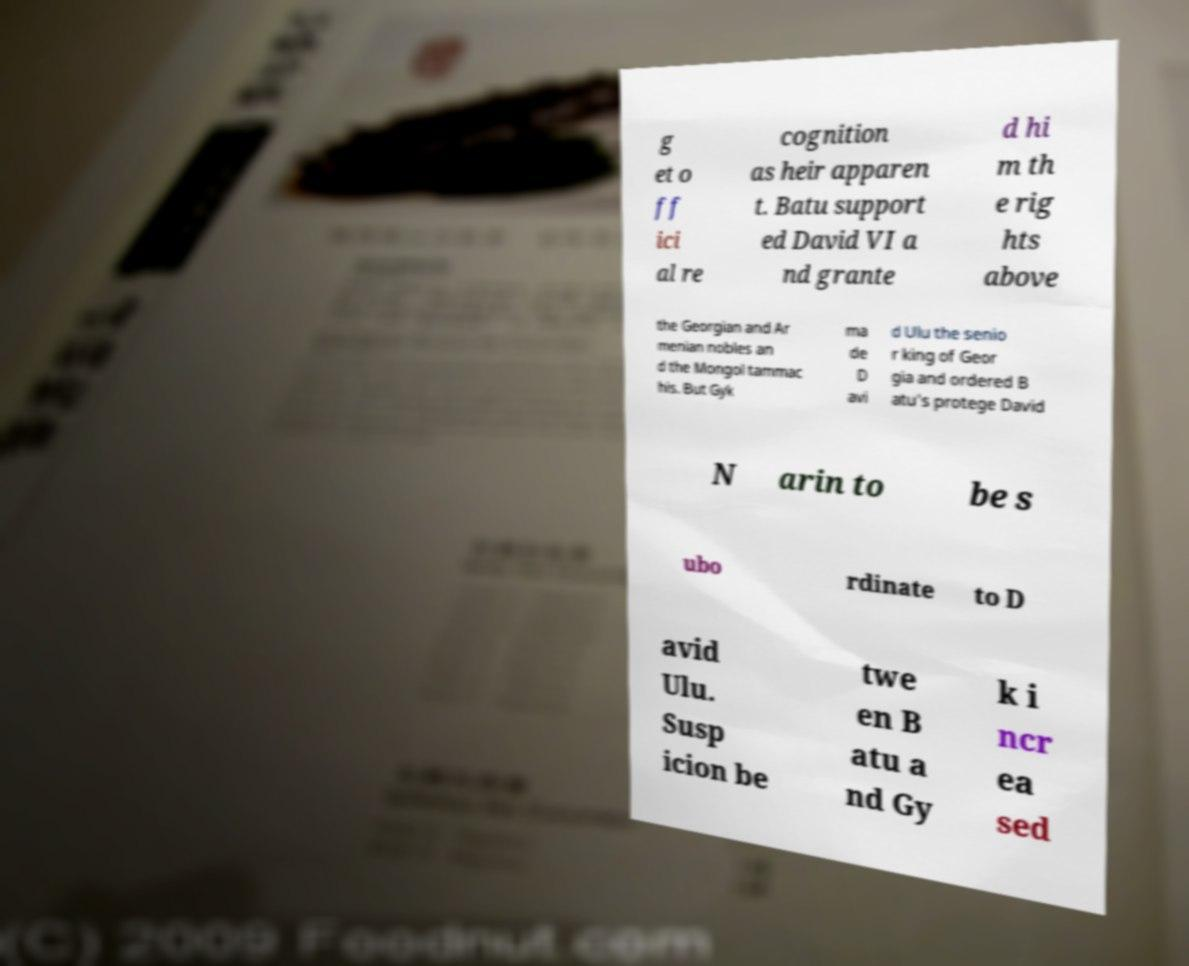Can you accurately transcribe the text from the provided image for me? g et o ff ici al re cognition as heir apparen t. Batu support ed David VI a nd grante d hi m th e rig hts above the Georgian and Ar menian nobles an d the Mongol tammac his. But Gyk ma de D avi d Ulu the senio r king of Geor gia and ordered B atu's protege David N arin to be s ubo rdinate to D avid Ulu. Susp icion be twe en B atu a nd Gy k i ncr ea sed 